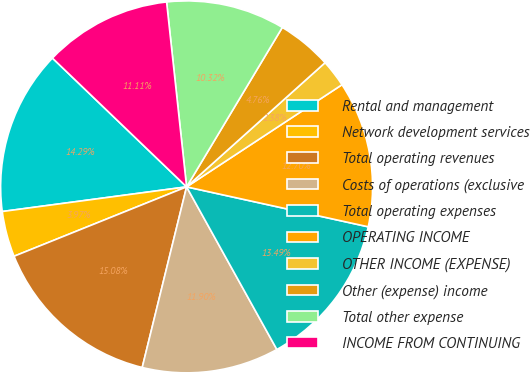<chart> <loc_0><loc_0><loc_500><loc_500><pie_chart><fcel>Rental and management<fcel>Network development services<fcel>Total operating revenues<fcel>Costs of operations (exclusive<fcel>Total operating expenses<fcel>OPERATING INCOME<fcel>OTHER INCOME (EXPENSE)<fcel>Other (expense) income<fcel>Total other expense<fcel>INCOME FROM CONTINUING<nl><fcel>14.29%<fcel>3.97%<fcel>15.08%<fcel>11.9%<fcel>13.49%<fcel>12.7%<fcel>2.38%<fcel>4.76%<fcel>10.32%<fcel>11.11%<nl></chart> 